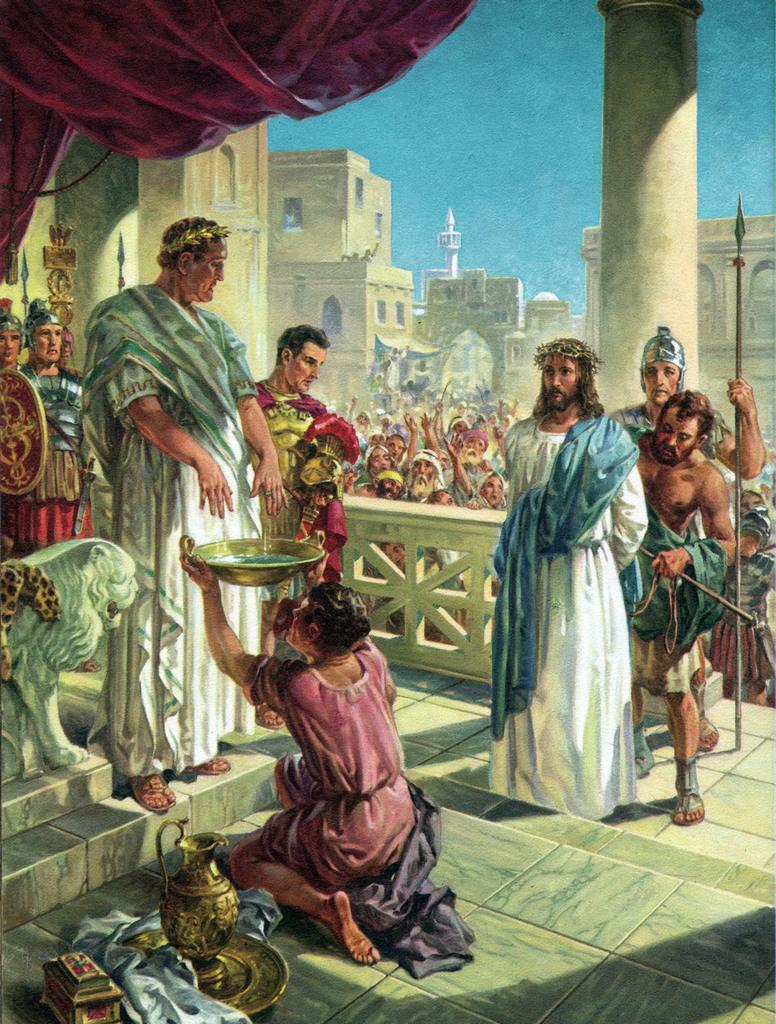How many people are in the image? There are people in the image, but the exact number is not specified. What can be seen in the background of the image? There is a fence, buildings, pillars, and the sky visible in the image. What is a person holding in the image? A person is holding a bowl in the image. What is on the floor in the image? There are things on the floor in the image. What is a man holding in the image? A man is holding a weapon in the image. Can you tell me how many ears of corn are visible in the image? There is no corn present in the image. What type of town can be seen in the background of the image? The image does not depict a town; it shows a fence, buildings, pillars, and the sky. 